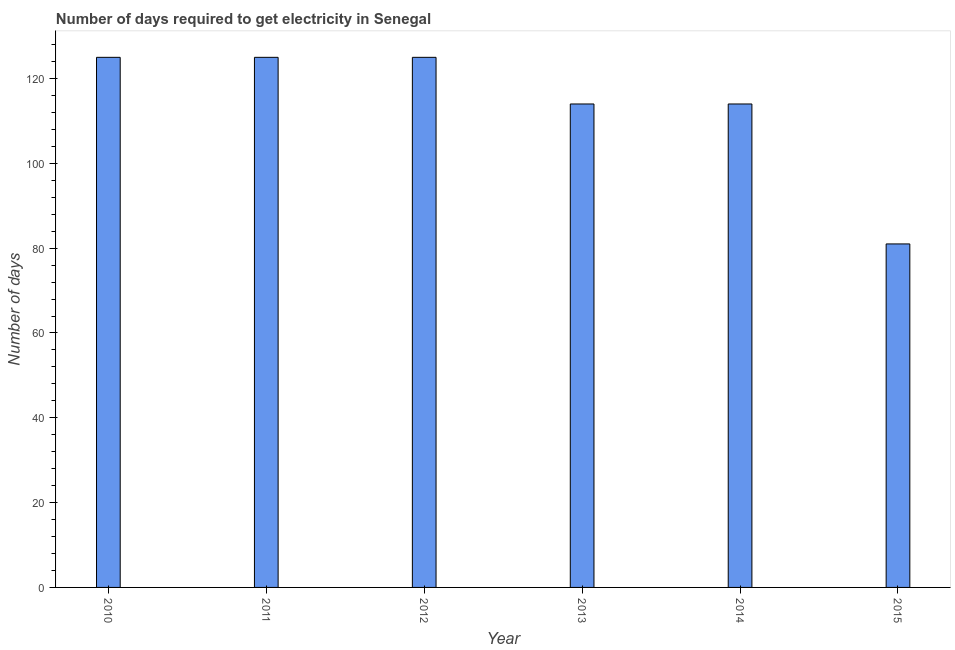Does the graph contain grids?
Give a very brief answer. No. What is the title of the graph?
Give a very brief answer. Number of days required to get electricity in Senegal. What is the label or title of the X-axis?
Your answer should be compact. Year. What is the label or title of the Y-axis?
Offer a very short reply. Number of days. What is the time to get electricity in 2011?
Offer a very short reply. 125. Across all years, what is the maximum time to get electricity?
Your response must be concise. 125. In which year was the time to get electricity maximum?
Give a very brief answer. 2010. In which year was the time to get electricity minimum?
Offer a terse response. 2015. What is the sum of the time to get electricity?
Your answer should be very brief. 684. What is the difference between the time to get electricity in 2010 and 2014?
Your response must be concise. 11. What is the average time to get electricity per year?
Your response must be concise. 114. What is the median time to get electricity?
Ensure brevity in your answer.  119.5. What is the ratio of the time to get electricity in 2013 to that in 2014?
Provide a succinct answer. 1. Is the difference between the time to get electricity in 2011 and 2012 greater than the difference between any two years?
Your answer should be very brief. No. What is the difference between the highest and the lowest time to get electricity?
Your answer should be very brief. 44. In how many years, is the time to get electricity greater than the average time to get electricity taken over all years?
Your response must be concise. 3. What is the difference between two consecutive major ticks on the Y-axis?
Your answer should be very brief. 20. What is the Number of days in 2010?
Offer a very short reply. 125. What is the Number of days in 2011?
Offer a terse response. 125. What is the Number of days in 2012?
Offer a very short reply. 125. What is the Number of days in 2013?
Keep it short and to the point. 114. What is the Number of days of 2014?
Offer a very short reply. 114. What is the Number of days in 2015?
Ensure brevity in your answer.  81. What is the difference between the Number of days in 2010 and 2012?
Keep it short and to the point. 0. What is the difference between the Number of days in 2010 and 2013?
Give a very brief answer. 11. What is the difference between the Number of days in 2010 and 2014?
Make the answer very short. 11. What is the difference between the Number of days in 2010 and 2015?
Offer a terse response. 44. What is the difference between the Number of days in 2011 and 2012?
Ensure brevity in your answer.  0. What is the difference between the Number of days in 2012 and 2013?
Make the answer very short. 11. What is the difference between the Number of days in 2014 and 2015?
Ensure brevity in your answer.  33. What is the ratio of the Number of days in 2010 to that in 2011?
Your answer should be very brief. 1. What is the ratio of the Number of days in 2010 to that in 2013?
Your response must be concise. 1.1. What is the ratio of the Number of days in 2010 to that in 2014?
Offer a very short reply. 1.1. What is the ratio of the Number of days in 2010 to that in 2015?
Give a very brief answer. 1.54. What is the ratio of the Number of days in 2011 to that in 2012?
Your answer should be compact. 1. What is the ratio of the Number of days in 2011 to that in 2013?
Ensure brevity in your answer.  1.1. What is the ratio of the Number of days in 2011 to that in 2014?
Ensure brevity in your answer.  1.1. What is the ratio of the Number of days in 2011 to that in 2015?
Provide a short and direct response. 1.54. What is the ratio of the Number of days in 2012 to that in 2013?
Give a very brief answer. 1.1. What is the ratio of the Number of days in 2012 to that in 2014?
Give a very brief answer. 1.1. What is the ratio of the Number of days in 2012 to that in 2015?
Ensure brevity in your answer.  1.54. What is the ratio of the Number of days in 2013 to that in 2014?
Ensure brevity in your answer.  1. What is the ratio of the Number of days in 2013 to that in 2015?
Keep it short and to the point. 1.41. What is the ratio of the Number of days in 2014 to that in 2015?
Provide a succinct answer. 1.41. 